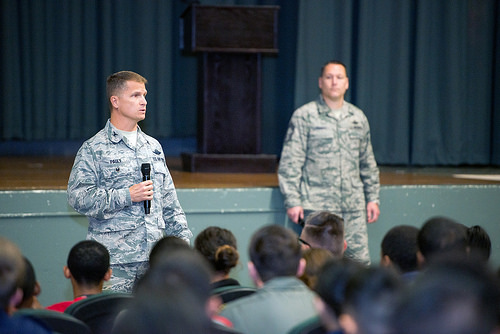<image>
Is there a stage behind the man? Yes. From this viewpoint, the stage is positioned behind the man, with the man partially or fully occluding the stage. 